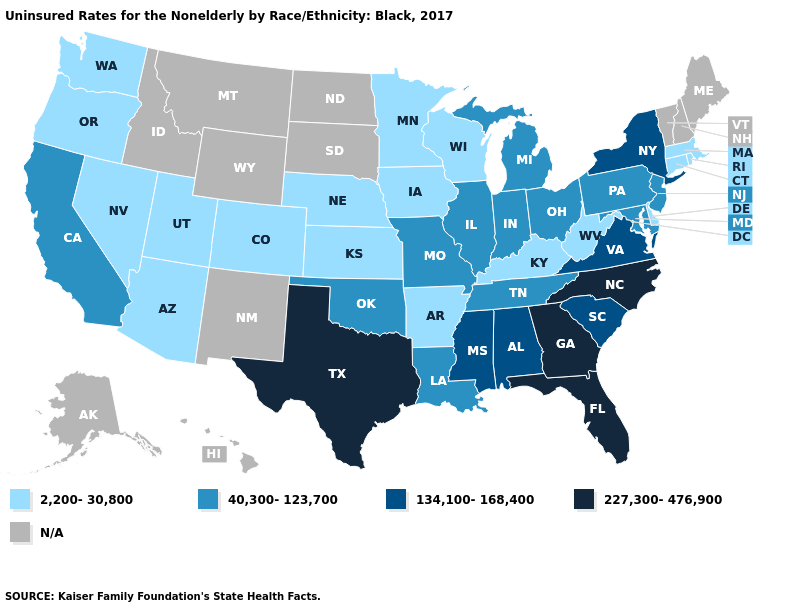Which states have the lowest value in the USA?
Give a very brief answer. Arizona, Arkansas, Colorado, Connecticut, Delaware, Iowa, Kansas, Kentucky, Massachusetts, Minnesota, Nebraska, Nevada, Oregon, Rhode Island, Utah, Washington, West Virginia, Wisconsin. What is the value of Nebraska?
Short answer required. 2,200-30,800. Does Florida have the highest value in the USA?
Short answer required. Yes. Among the states that border Connecticut , which have the highest value?
Quick response, please. New York. What is the value of North Dakota?
Concise answer only. N/A. Does Arizona have the highest value in the West?
Be succinct. No. Which states hav the highest value in the West?
Short answer required. California. Which states have the lowest value in the MidWest?
Be succinct. Iowa, Kansas, Minnesota, Nebraska, Wisconsin. Does Illinois have the highest value in the MidWest?
Keep it brief. Yes. What is the value of Oklahoma?
Keep it brief. 40,300-123,700. What is the lowest value in the South?
Keep it brief. 2,200-30,800. Does Minnesota have the highest value in the USA?
Quick response, please. No. What is the value of Oregon?
Concise answer only. 2,200-30,800. What is the value of Georgia?
Concise answer only. 227,300-476,900. 